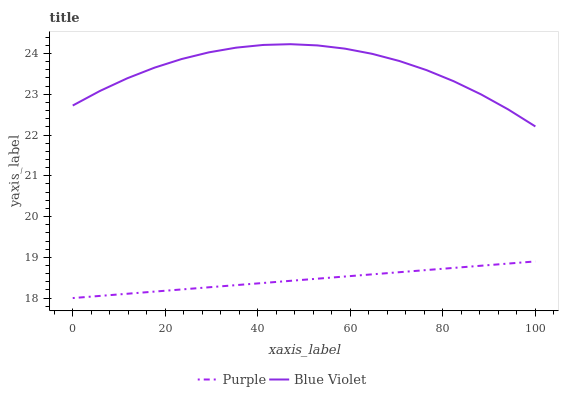Does Purple have the minimum area under the curve?
Answer yes or no. Yes. Does Blue Violet have the maximum area under the curve?
Answer yes or no. Yes. Does Blue Violet have the minimum area under the curve?
Answer yes or no. No. Is Purple the smoothest?
Answer yes or no. Yes. Is Blue Violet the roughest?
Answer yes or no. Yes. Is Blue Violet the smoothest?
Answer yes or no. No. Does Purple have the lowest value?
Answer yes or no. Yes. Does Blue Violet have the lowest value?
Answer yes or no. No. Does Blue Violet have the highest value?
Answer yes or no. Yes. Is Purple less than Blue Violet?
Answer yes or no. Yes. Is Blue Violet greater than Purple?
Answer yes or no. Yes. Does Purple intersect Blue Violet?
Answer yes or no. No. 